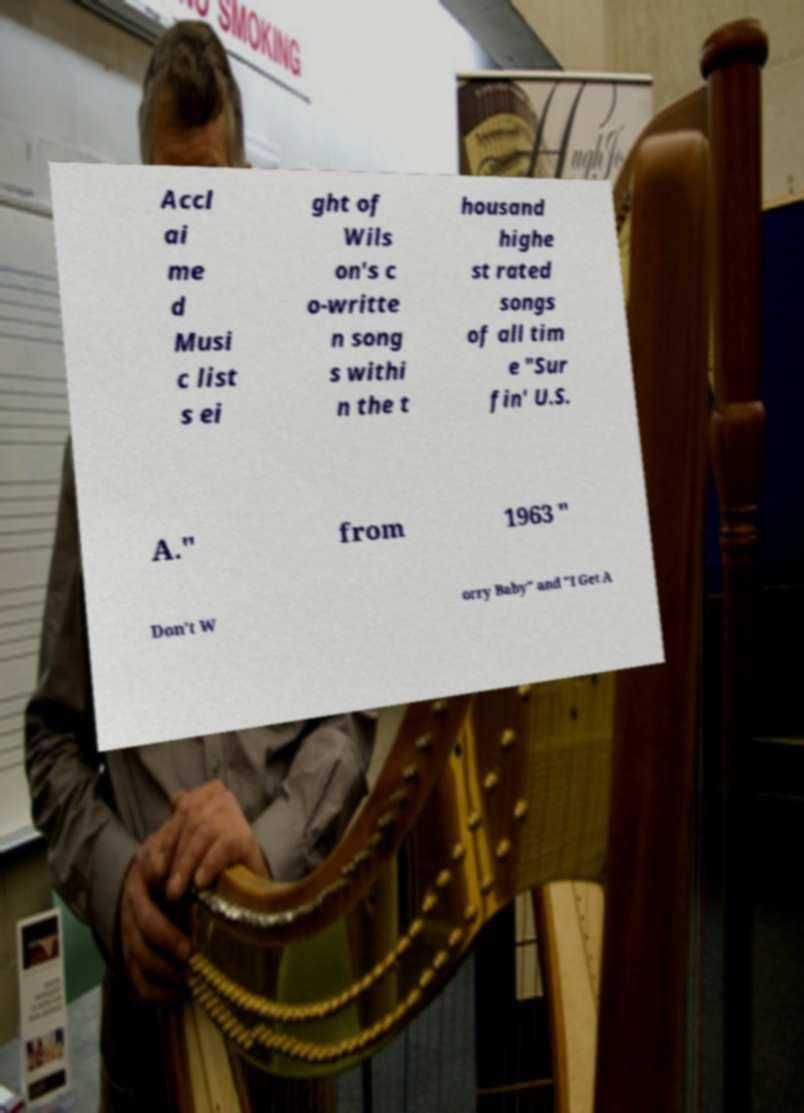Please identify and transcribe the text found in this image. Accl ai me d Musi c list s ei ght of Wils on's c o-writte n song s withi n the t housand highe st rated songs of all tim e "Sur fin' U.S. A." from 1963 " Don't W orry Baby" and "I Get A 